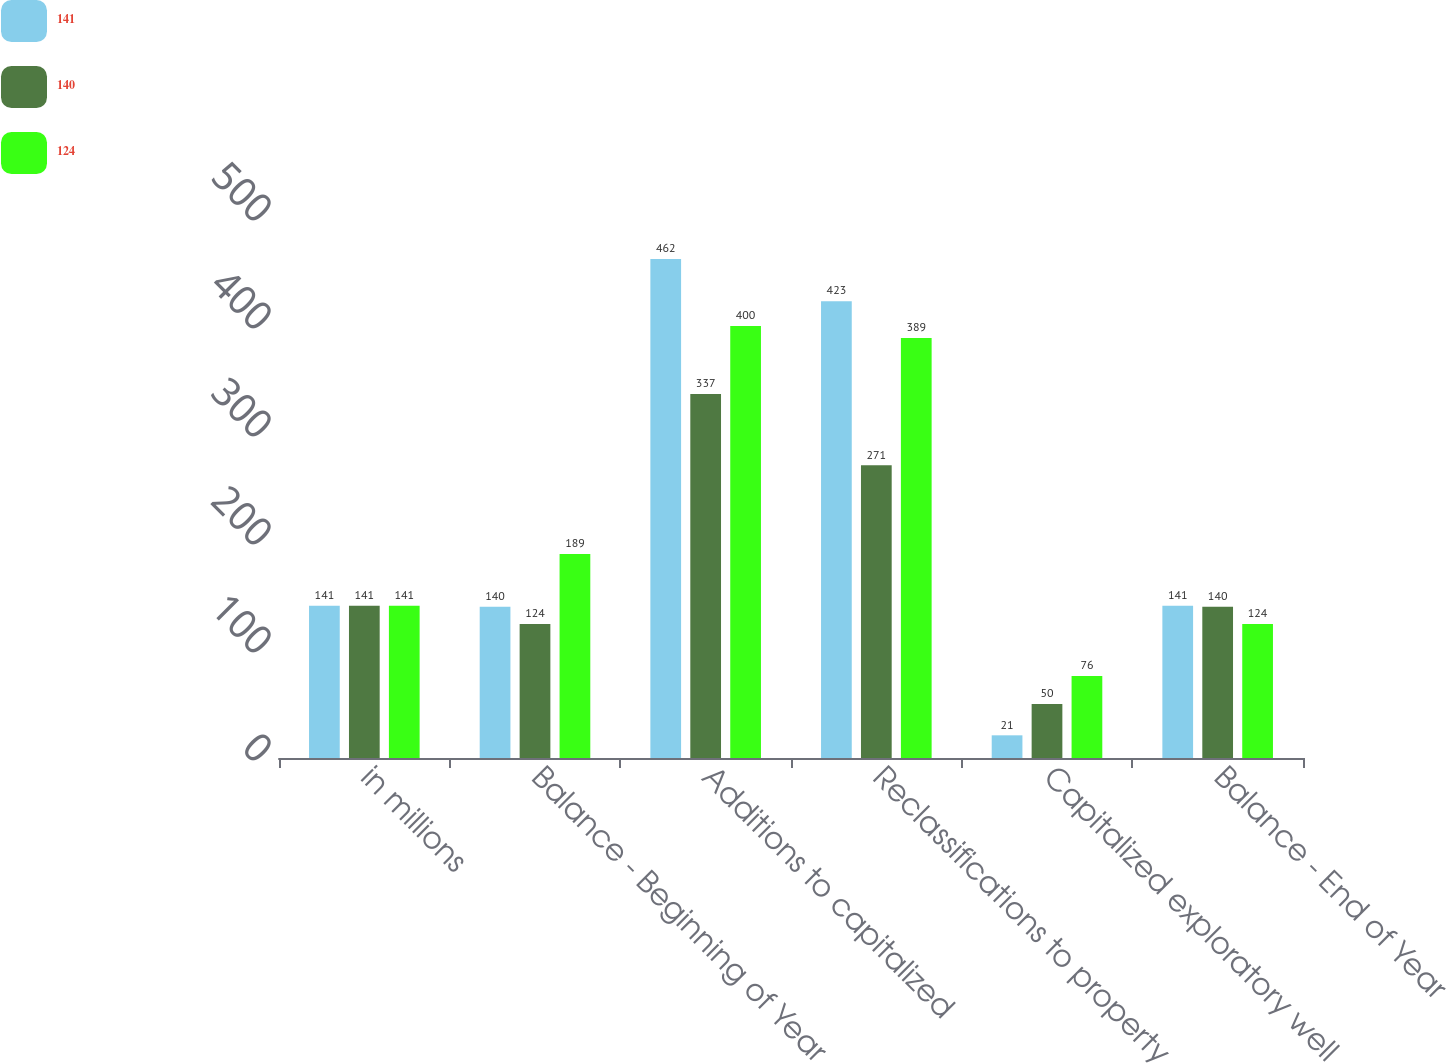Convert chart to OTSL. <chart><loc_0><loc_0><loc_500><loc_500><stacked_bar_chart><ecel><fcel>in millions<fcel>Balance - Beginning of Year<fcel>Additions to capitalized<fcel>Reclassifications to property<fcel>Capitalized exploratory well<fcel>Balance - End of Year<nl><fcel>141<fcel>141<fcel>140<fcel>462<fcel>423<fcel>21<fcel>141<nl><fcel>140<fcel>141<fcel>124<fcel>337<fcel>271<fcel>50<fcel>140<nl><fcel>124<fcel>141<fcel>189<fcel>400<fcel>389<fcel>76<fcel>124<nl></chart> 